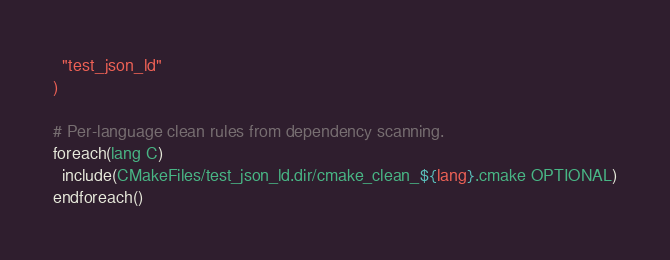<code> <loc_0><loc_0><loc_500><loc_500><_CMake_>  "test_json_ld"
)

# Per-language clean rules from dependency scanning.
foreach(lang C)
  include(CMakeFiles/test_json_ld.dir/cmake_clean_${lang}.cmake OPTIONAL)
endforeach()
</code> 